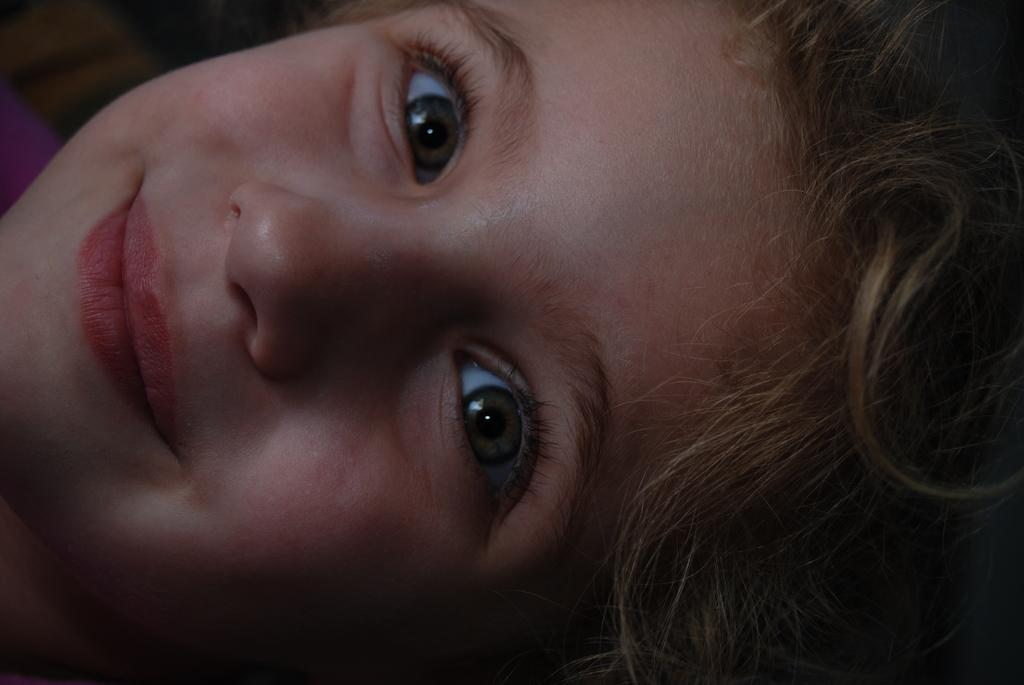What is the main subject of the image? There is a face of a person in the image. What type of ocean can be seen in the background of the image? There is no ocean present in the image; it only features the face of a person. 